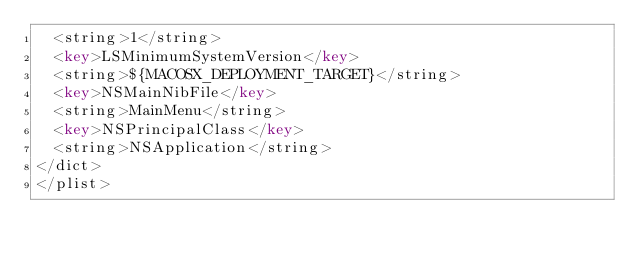Convert code to text. <code><loc_0><loc_0><loc_500><loc_500><_XML_>	<string>1</string>
	<key>LSMinimumSystemVersion</key>
	<string>${MACOSX_DEPLOYMENT_TARGET}</string>
	<key>NSMainNibFile</key>
	<string>MainMenu</string>
	<key>NSPrincipalClass</key>
	<string>NSApplication</string>
</dict>
</plist>
</code> 